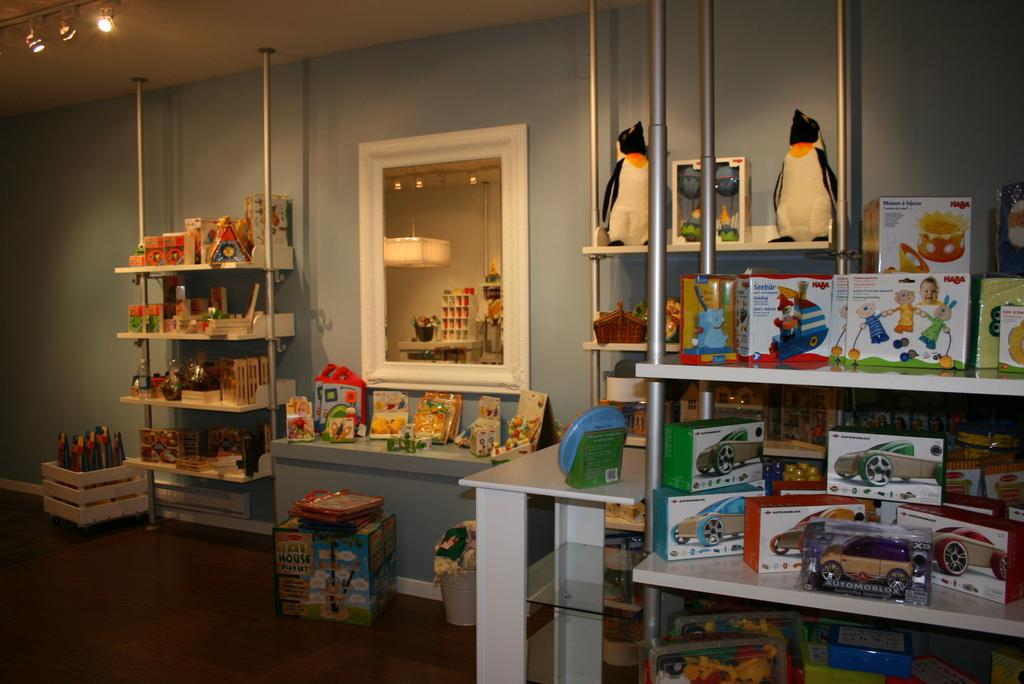<image>
Offer a succinct explanation of the picture presented. A big box containing a "Tree House Play Set" sits on the floor in front of a bench. 